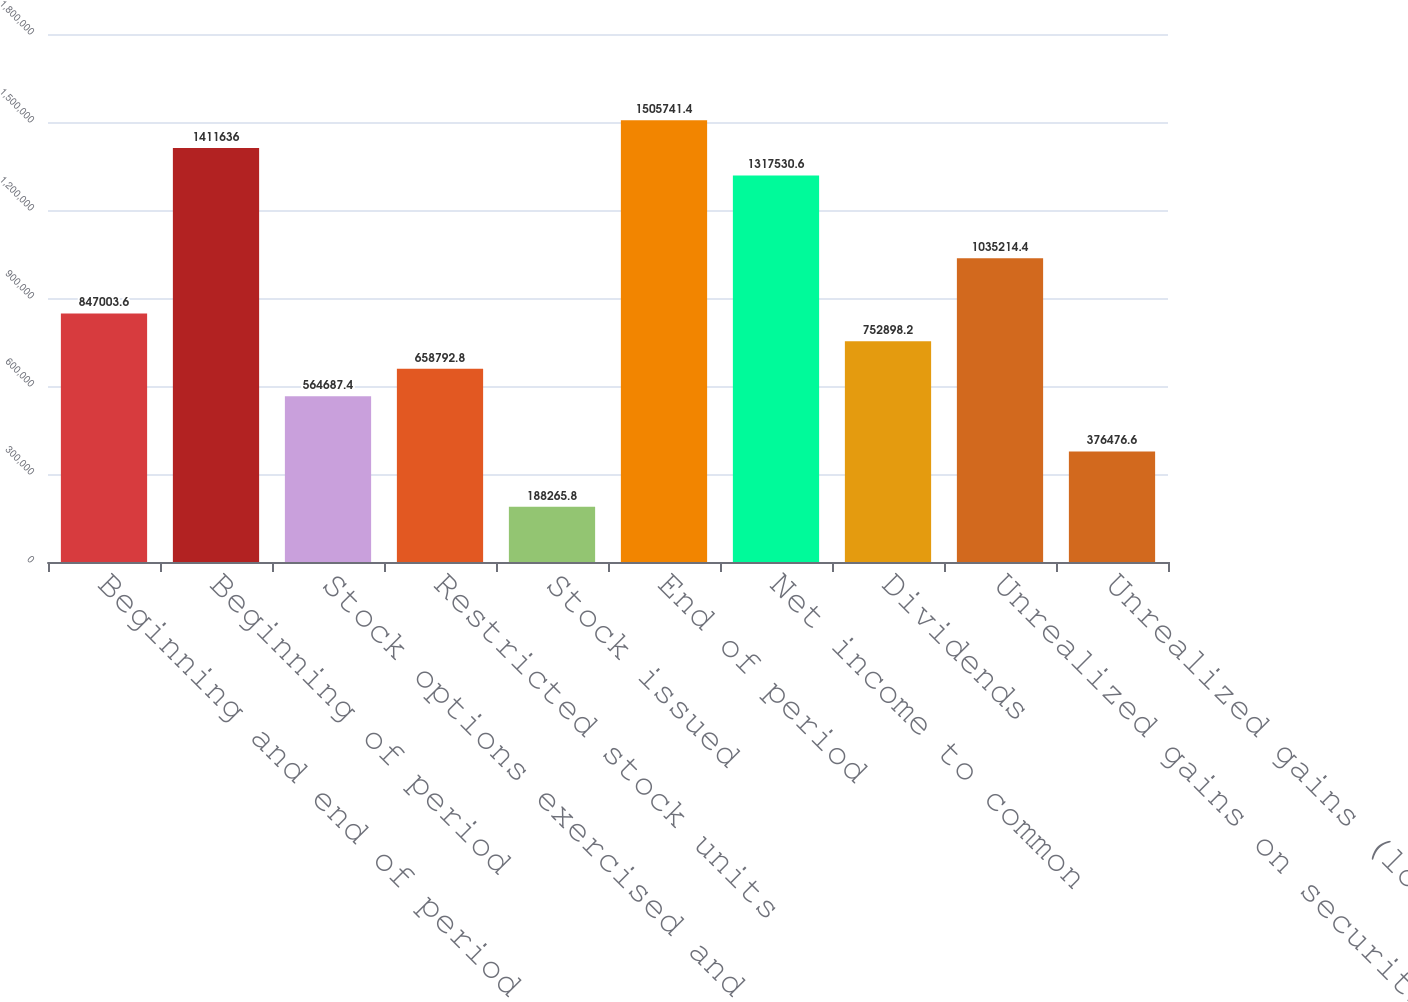<chart> <loc_0><loc_0><loc_500><loc_500><bar_chart><fcel>Beginning and end of period<fcel>Beginning of period<fcel>Stock options exercised and<fcel>Restricted stock units<fcel>Stock issued<fcel>End of period<fcel>Net income to common<fcel>Dividends<fcel>Unrealized gains on securities<fcel>Unrealized gains (losses) on<nl><fcel>847004<fcel>1.41164e+06<fcel>564687<fcel>658793<fcel>188266<fcel>1.50574e+06<fcel>1.31753e+06<fcel>752898<fcel>1.03521e+06<fcel>376477<nl></chart> 